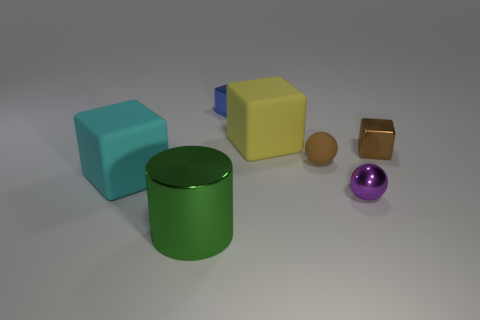Add 2 large gray metallic cylinders. How many objects exist? 9 Subtract all balls. How many objects are left? 5 Add 2 brown metal blocks. How many brown metal blocks exist? 3 Subtract 0 gray spheres. How many objects are left? 7 Subtract all tiny green metallic spheres. Subtract all green metal cylinders. How many objects are left? 6 Add 7 brown metallic objects. How many brown metallic objects are left? 8 